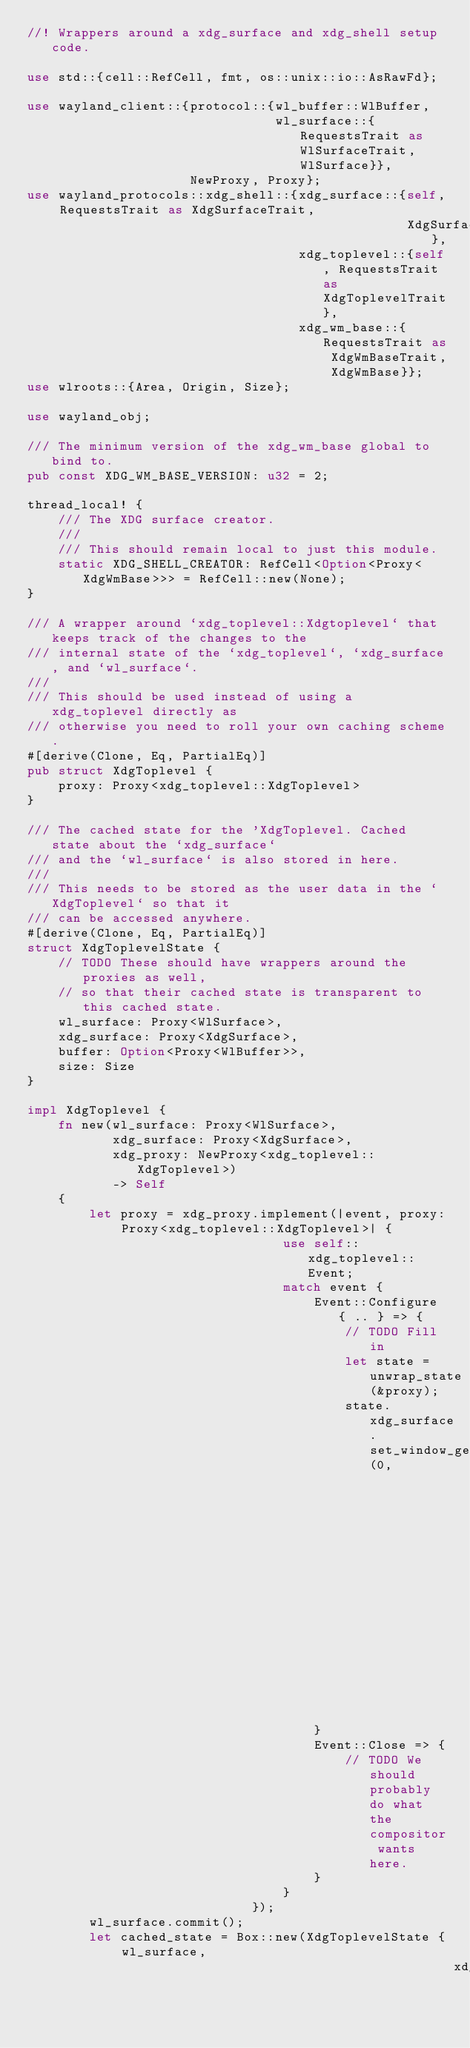<code> <loc_0><loc_0><loc_500><loc_500><_Rust_>//! Wrappers around a xdg_surface and xdg_shell setup code.

use std::{cell::RefCell, fmt, os::unix::io::AsRawFd};

use wayland_client::{protocol::{wl_buffer::WlBuffer,
                                wl_surface::{RequestsTrait as WlSurfaceTrait, WlSurface}},
                     NewProxy, Proxy};
use wayland_protocols::xdg_shell::{xdg_surface::{self, RequestsTrait as XdgSurfaceTrait,
                                                 XdgSurface},
                                   xdg_toplevel::{self, RequestsTrait as XdgToplevelTrait},
                                   xdg_wm_base::{RequestsTrait as XdgWmBaseTrait, XdgWmBase}};
use wlroots::{Area, Origin, Size};

use wayland_obj;

/// The minimum version of the xdg_wm_base global to bind to.
pub const XDG_WM_BASE_VERSION: u32 = 2;

thread_local! {
    /// The XDG surface creator.
    ///
    /// This should remain local to just this module.
    static XDG_SHELL_CREATOR: RefCell<Option<Proxy<XdgWmBase>>> = RefCell::new(None);
}

/// A wrapper around `xdg_toplevel::Xdgtoplevel` that keeps track of the changes to the
/// internal state of the `xdg_toplevel`, `xdg_surface, and `wl_surface`.
///
/// This should be used instead of using a xdg_toplevel directly as
/// otherwise you need to roll your own caching scheme.
#[derive(Clone, Eq, PartialEq)]
pub struct XdgToplevel {
    proxy: Proxy<xdg_toplevel::XdgToplevel>
}

/// The cached state for the 'XdgToplevel. Cached state about the `xdg_surface`
/// and the `wl_surface` is also stored in here.
///
/// This needs to be stored as the user data in the `XdgToplevel` so that it
/// can be accessed anywhere.
#[derive(Clone, Eq, PartialEq)]
struct XdgToplevelState {
    // TODO These should have wrappers around the proxies as well,
    // so that their cached state is transparent to this cached state.
    wl_surface: Proxy<WlSurface>,
    xdg_surface: Proxy<XdgSurface>,
    buffer: Option<Proxy<WlBuffer>>,
    size: Size
}

impl XdgToplevel {
    fn new(wl_surface: Proxy<WlSurface>,
           xdg_surface: Proxy<XdgSurface>,
           xdg_proxy: NewProxy<xdg_toplevel::XdgToplevel>)
           -> Self
    {
        let proxy = xdg_proxy.implement(|event, proxy: Proxy<xdg_toplevel::XdgToplevel>| {
                                 use self::xdg_toplevel::Event;
                                 match event {
                                     Event::Configure { .. } => {
                                         // TODO Fill in
                                         let state = unwrap_state(&proxy);
                                         state.xdg_surface.set_window_geometry(0,
                                                                               0,
                                                                               state.size.width,
                                                                               state.size.height);
                                     }
                                     Event::Close => {
                                         // TODO We should probably do what the compositor wants here.
                                     }
                                 }
                             });
        wl_surface.commit();
        let cached_state = Box::new(XdgToplevelState { wl_surface,
                                                       xdg_surface,</code> 